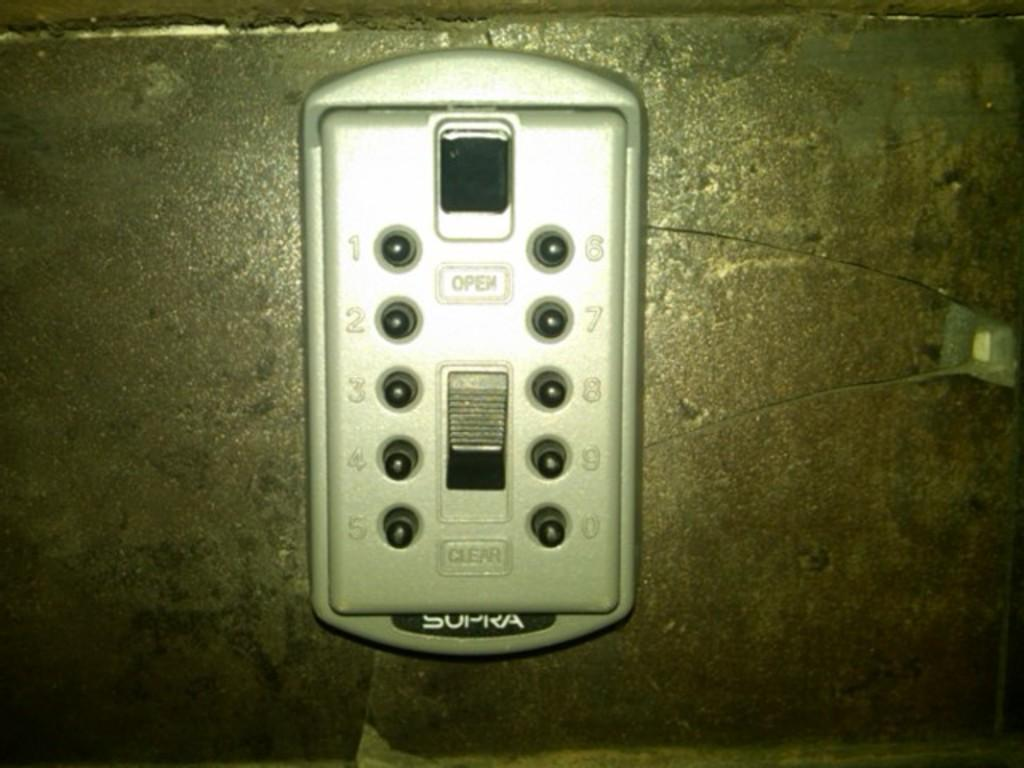<image>
Offer a succinct explanation of the picture presented. A plate with buttons on it is made by Supra. 